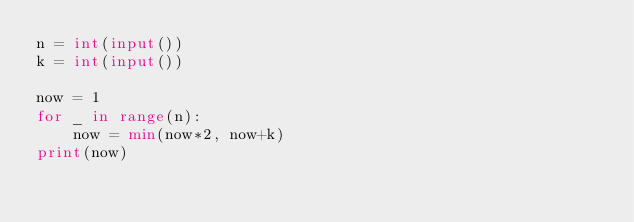<code> <loc_0><loc_0><loc_500><loc_500><_Python_>n = int(input())
k = int(input())

now = 1
for _ in range(n):
    now = min(now*2, now+k)
print(now)</code> 